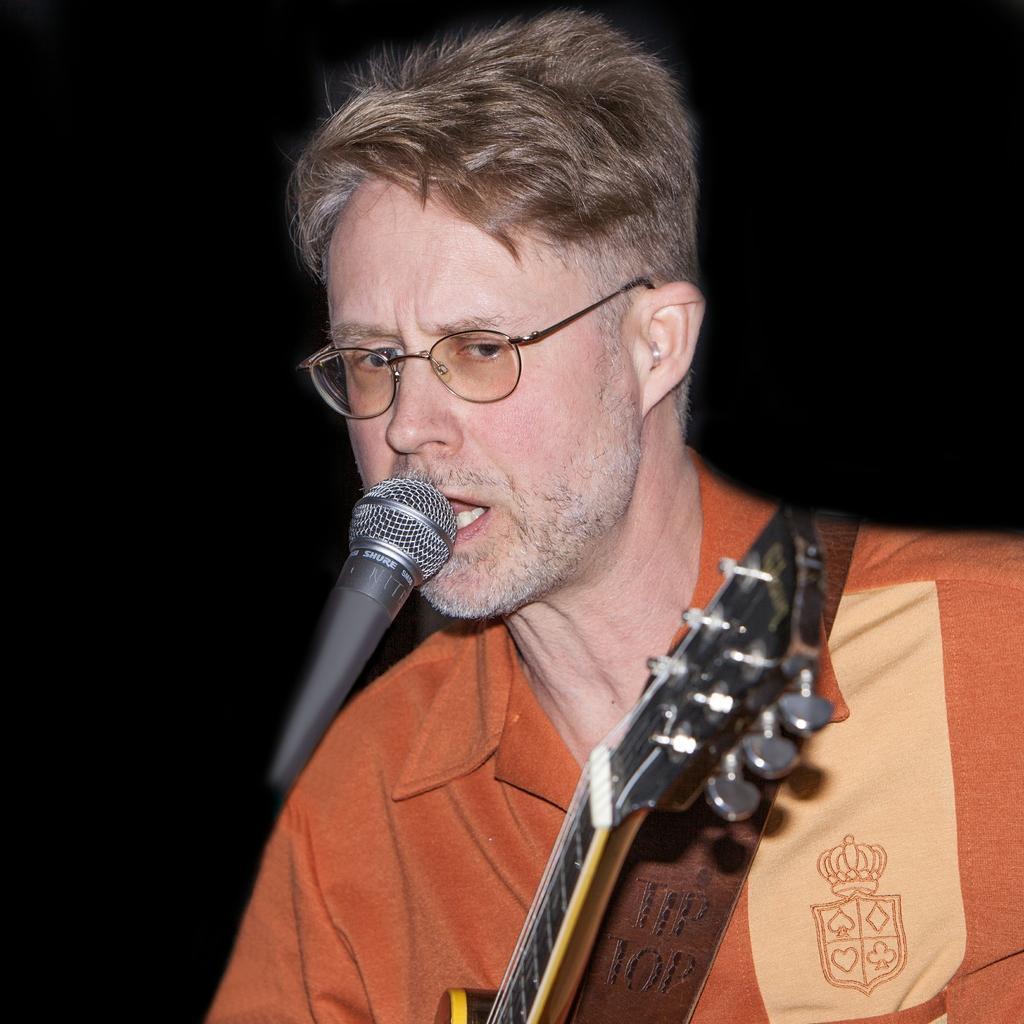In one or two sentences, can you explain what this image depicts? The picture consists of only one person wearing a orange t-shirt and holding a guitar and singing in front of the microphone and he is wearing glasses. 